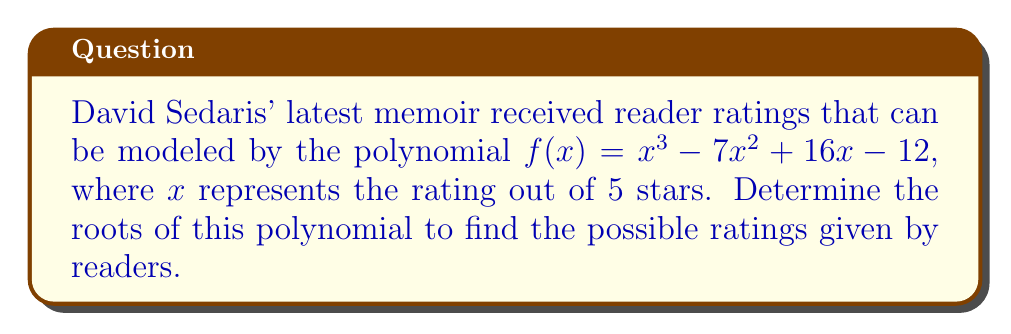Can you answer this question? To find the roots of the polynomial $f(x) = x^3 - 7x^2 + 16x - 12$, we need to factor it.

Step 1: Check for rational roots using the rational root theorem.
Possible rational roots: $\pm 1, \pm 2, \pm 3, \pm 4, \pm 6, \pm 12$

Step 2: Use synthetic division to test these potential roots.
Testing $x = 1$:
$$ 1 \quad -7 \quad 16 \quad -12 $$
$$ \quad 1 \quad -6 \quad 10 $$
$$ 1 \quad -6 \quad 10 \quad -2 $$

Since the remainder is -2, $x = 1$ is not a root.

Testing $x = 2$:
$$ 1 \quad -7 \quad 16 \quad -12 $$
$$ \quad 2 \quad -10 \quad 12 $$
$$ 1 \quad -5 \quad 6 \quad 0 $$

The remainder is 0, so $x = 2$ is a root.

Step 3: Factor out $(x - 2)$ from the original polynomial.
$f(x) = (x - 2)(x^2 - 5x + 6)$

Step 4: Factor the quadratic term $x^2 - 5x + 6$.
$(x - 2)(x - 3)(x - 2)$

Therefore, the roots of the polynomial are $x = 2$ (twice) and $x = 3$.
Answer: $x = 2$ (double root), $x = 3$ 